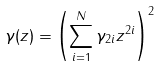Convert formula to latex. <formula><loc_0><loc_0><loc_500><loc_500>\gamma ( z ) = \left ( \sum _ { i = 1 } ^ { N } \gamma _ { 2 i } z ^ { 2 i } \right ) ^ { 2 }</formula> 